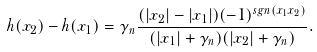<formula> <loc_0><loc_0><loc_500><loc_500>h ( x _ { 2 } ) - h ( x _ { 1 } ) = \gamma _ { n } \frac { ( | x _ { 2 } | - | x _ { 1 } | ) ( - 1 ) ^ { s g n ( x _ { 1 } x _ { 2 } ) } } { ( | x _ { 1 } | + \gamma _ { n } ) ( | x _ { 2 } | + \gamma _ { n } ) } .</formula> 